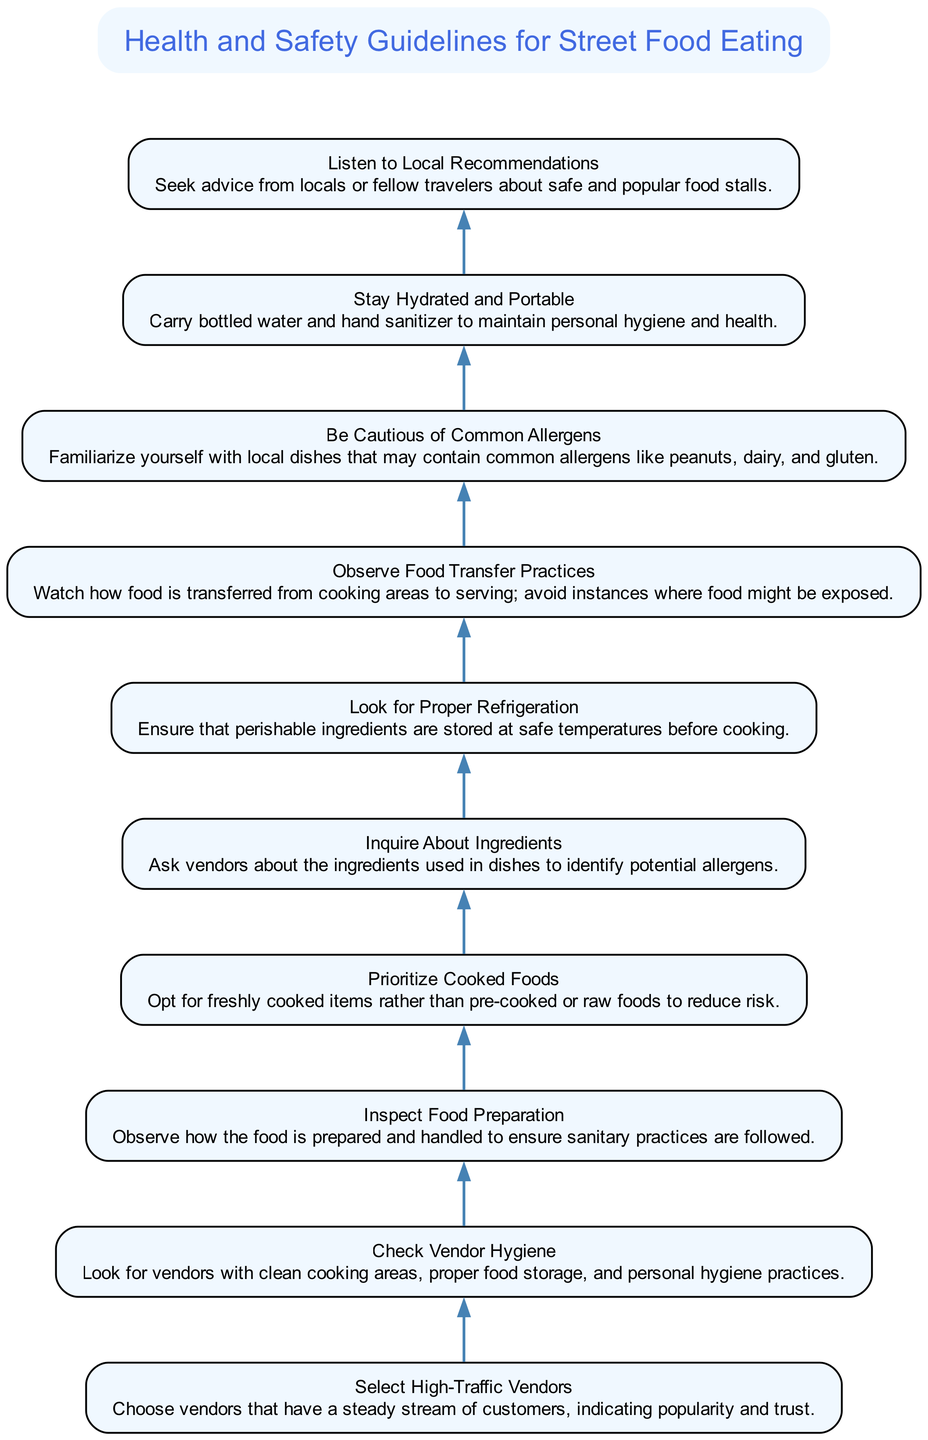What is the first step in the flow chart? The first step is "Select High-Traffic Vendors," which is the topmost node in the diagram. This indicates that it is the initial action to consider when ensuring safe street food consumption.
Answer: Select High-Traffic Vendors How many total elements are present in the diagram? The diagram contains a total of 10 elements, including the title node. Each element represents a step or guideline for ensuring safe street food consumption.
Answer: 10 What is the last step listed in the flow chart? The last step is "Listen to Local Recommendations," which is the final action to consider according to the flow of the diagram. This step emphasizes the importance of local insights in making safe food choices.
Answer: Listen to Local Recommendations Which step directly precedes "Inspect Food Preparation"? The step that directly precedes "Inspect Food Preparation" is "Check Vendor Hygiene." This shows that checking the vendor's hygiene practices comes before inspecting how the food is handled.
Answer: Check Vendor Hygiene What is the relationship between "Stay Hydrated and Portable" and "Listen to Local Recommendations"? "Stay Hydrated and Portable" is positioned above "Listen to Local Recommendations" in the flow chart. This indicates that maintaining personal hydration and hygiene is a guideline that should be considered alongside seeking local advice.
Answer: Above How many guidelines focus on observing vendor practices? There are three guidelines that focus on observing vendor practices: "Check Vendor Hygiene," "Inspect Food Preparation," and "Observe Food Transfer Practices." These steps emphasize the importance of monitoring the vendor's actions to ensure food safety.
Answer: 3 Which two steps are directly connected by an edge in the flow chart? There is a direct connection by an edge between "Look for Proper Refrigeration" and "Prioritize Cooked Foods." This indicates that ensuring proper refrigeration is a prerequisite for choosing cooked food options.
Answer: Look for Proper Refrigeration and Prioritize Cooked Foods What do the nodes collectively emphasize about street food consumption? The nodes collectively emphasize guidelines for health and safety, focusing on vendor selection, hygiene practices, and awareness of allergens to ensure safe food consumption.
Answer: Health and Safety Guidelines 